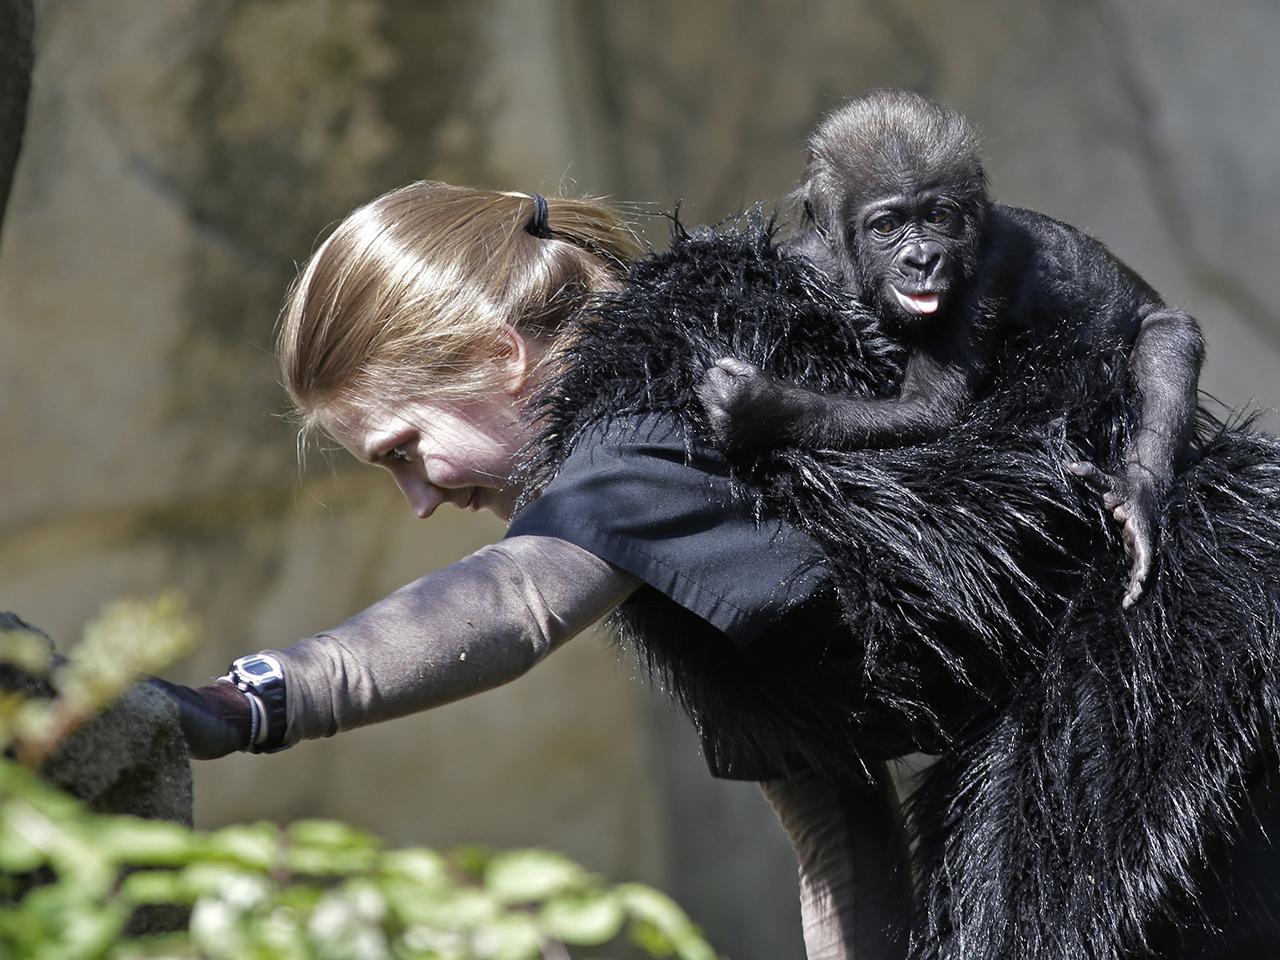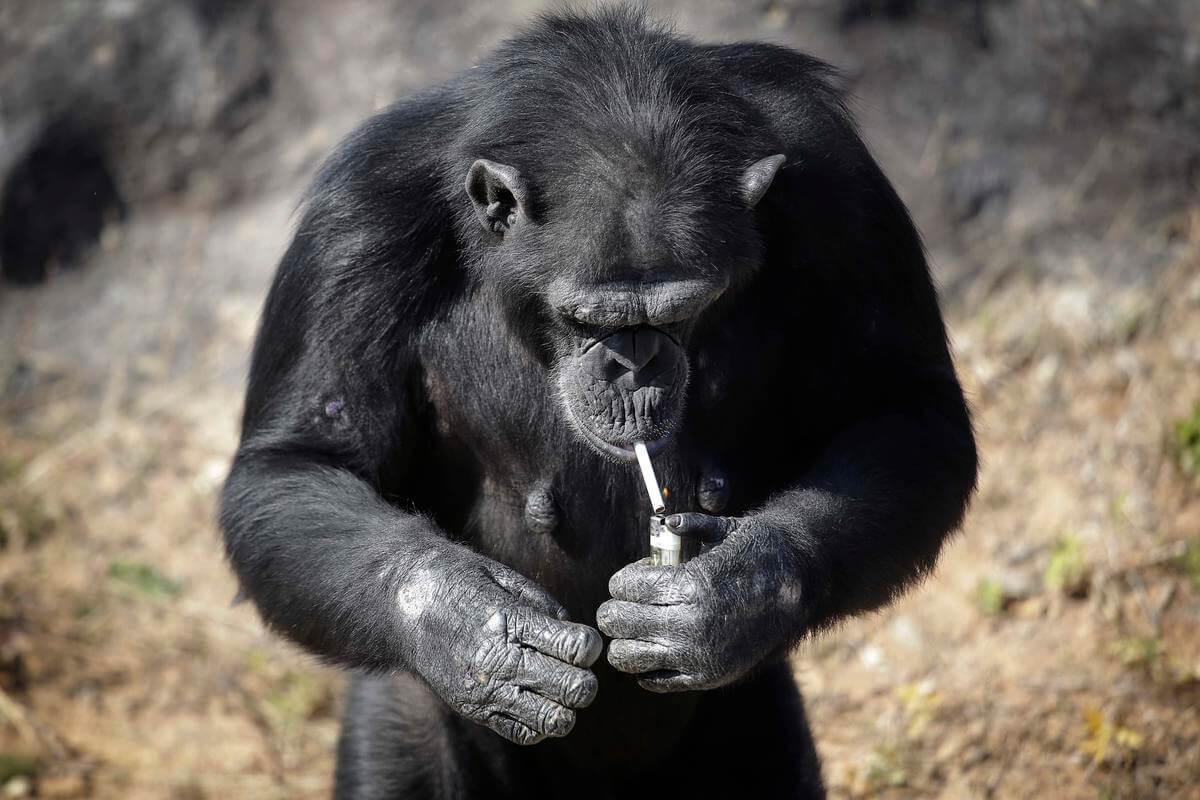The first image is the image on the left, the second image is the image on the right. Given the left and right images, does the statement "An image shows an adult chimpanzee hugging a younger awake chimpanzee to its chest." hold true? Answer yes or no. No. The first image is the image on the left, the second image is the image on the right. Considering the images on both sides, is "A single young primate is lying down in the image on the right." valid? Answer yes or no. No. 